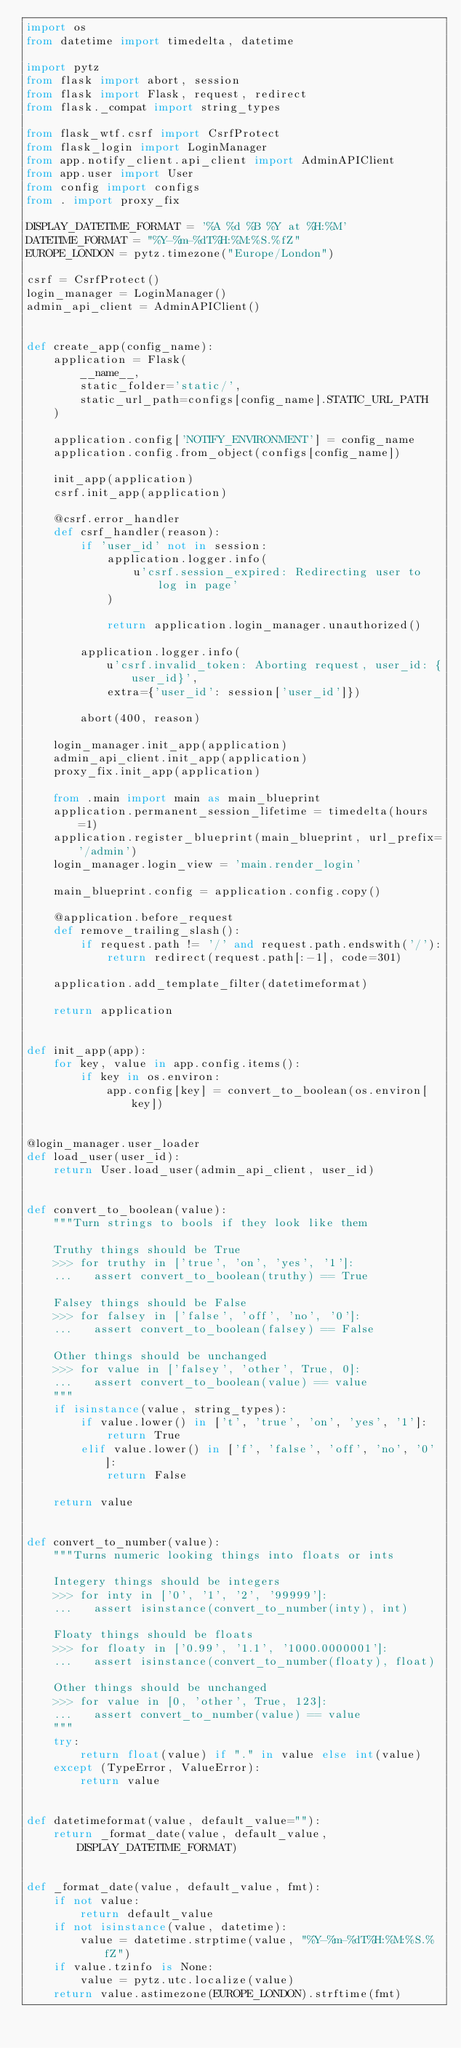<code> <loc_0><loc_0><loc_500><loc_500><_Python_>import os
from datetime import timedelta, datetime

import pytz
from flask import abort, session
from flask import Flask, request, redirect
from flask._compat import string_types

from flask_wtf.csrf import CsrfProtect
from flask_login import LoginManager
from app.notify_client.api_client import AdminAPIClient
from app.user import User
from config import configs
from . import proxy_fix

DISPLAY_DATETIME_FORMAT = '%A %d %B %Y at %H:%M'
DATETIME_FORMAT = "%Y-%m-%dT%H:%M:%S.%fZ"
EUROPE_LONDON = pytz.timezone("Europe/London")

csrf = CsrfProtect()
login_manager = LoginManager()
admin_api_client = AdminAPIClient()


def create_app(config_name):
    application = Flask(
        __name__,
        static_folder='static/',
        static_url_path=configs[config_name].STATIC_URL_PATH
    )

    application.config['NOTIFY_ENVIRONMENT'] = config_name
    application.config.from_object(configs[config_name])

    init_app(application)
    csrf.init_app(application)

    @csrf.error_handler
    def csrf_handler(reason):
        if 'user_id' not in session:
            application.logger.info(
                u'csrf.session_expired: Redirecting user to log in page'
            )

            return application.login_manager.unauthorized()

        application.logger.info(
            u'csrf.invalid_token: Aborting request, user_id: {user_id}',
            extra={'user_id': session['user_id']})

        abort(400, reason)

    login_manager.init_app(application)
    admin_api_client.init_app(application)
    proxy_fix.init_app(application)

    from .main import main as main_blueprint
    application.permanent_session_lifetime = timedelta(hours=1)
    application.register_blueprint(main_blueprint, url_prefix='/admin')
    login_manager.login_view = 'main.render_login'

    main_blueprint.config = application.config.copy()

    @application.before_request
    def remove_trailing_slash():
        if request.path != '/' and request.path.endswith('/'):
            return redirect(request.path[:-1], code=301)

    application.add_template_filter(datetimeformat)

    return application


def init_app(app):
    for key, value in app.config.items():
        if key in os.environ:
            app.config[key] = convert_to_boolean(os.environ[key])


@login_manager.user_loader
def load_user(user_id):
    return User.load_user(admin_api_client, user_id)


def convert_to_boolean(value):
    """Turn strings to bools if they look like them

    Truthy things should be True
    >>> for truthy in ['true', 'on', 'yes', '1']:
    ...   assert convert_to_boolean(truthy) == True

    Falsey things should be False
    >>> for falsey in ['false', 'off', 'no', '0']:
    ...   assert convert_to_boolean(falsey) == False

    Other things should be unchanged
    >>> for value in ['falsey', 'other', True, 0]:
    ...   assert convert_to_boolean(value) == value
    """
    if isinstance(value, string_types):
        if value.lower() in ['t', 'true', 'on', 'yes', '1']:
            return True
        elif value.lower() in ['f', 'false', 'off', 'no', '0']:
            return False

    return value


def convert_to_number(value):
    """Turns numeric looking things into floats or ints

    Integery things should be integers
    >>> for inty in ['0', '1', '2', '99999']:
    ...   assert isinstance(convert_to_number(inty), int)

    Floaty things should be floats
    >>> for floaty in ['0.99', '1.1', '1000.0000001']:
    ...   assert isinstance(convert_to_number(floaty), float)

    Other things should be unchanged
    >>> for value in [0, 'other', True, 123]:
    ...   assert convert_to_number(value) == value
    """
    try:
        return float(value) if "." in value else int(value)
    except (TypeError, ValueError):
        return value


def datetimeformat(value, default_value=""):
    return _format_date(value, default_value, DISPLAY_DATETIME_FORMAT)


def _format_date(value, default_value, fmt):
    if not value:
        return default_value
    if not isinstance(value, datetime):
        value = datetime.strptime(value, "%Y-%m-%dT%H:%M:%S.%fZ")
    if value.tzinfo is None:
        value = pytz.utc.localize(value)
    return value.astimezone(EUROPE_LONDON).strftime(fmt)
</code> 